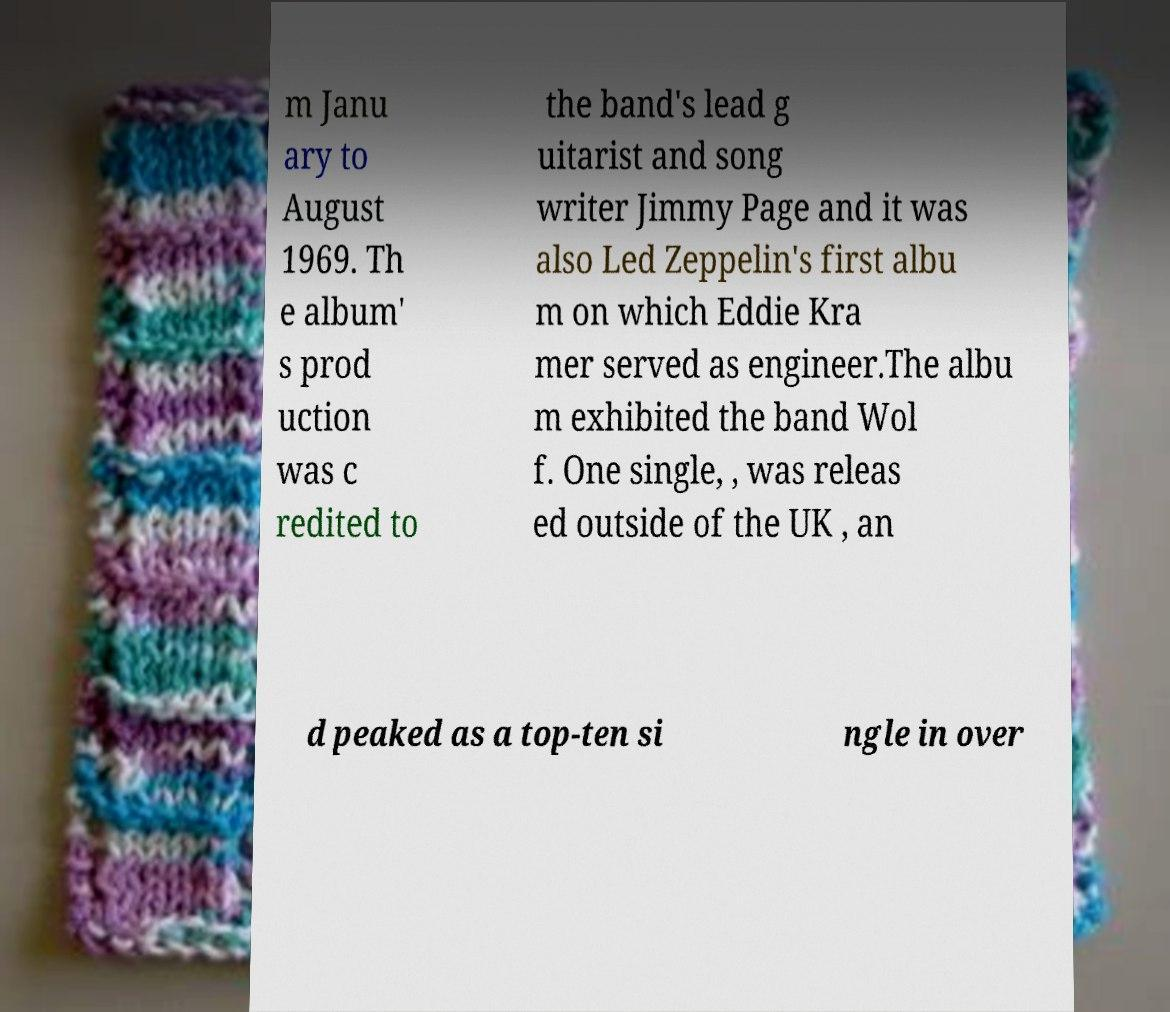What messages or text are displayed in this image? I need them in a readable, typed format. m Janu ary to August 1969. Th e album' s prod uction was c redited to the band's lead g uitarist and song writer Jimmy Page and it was also Led Zeppelin's first albu m on which Eddie Kra mer served as engineer.The albu m exhibited the band Wol f. One single, , was releas ed outside of the UK , an d peaked as a top-ten si ngle in over 